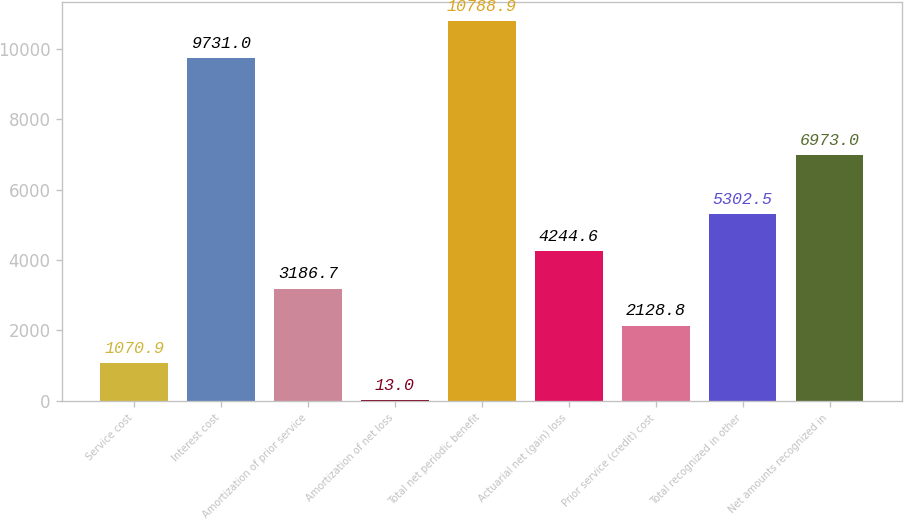Convert chart. <chart><loc_0><loc_0><loc_500><loc_500><bar_chart><fcel>Service cost<fcel>Interest cost<fcel>Amortization of prior service<fcel>Amortization of net loss<fcel>Total net periodic benefit<fcel>Actuarial net (gain) loss<fcel>Prior service (credit) cost<fcel>Total recognized in other<fcel>Net amounts recognized in<nl><fcel>1070.9<fcel>9731<fcel>3186.7<fcel>13<fcel>10788.9<fcel>4244.6<fcel>2128.8<fcel>5302.5<fcel>6973<nl></chart> 